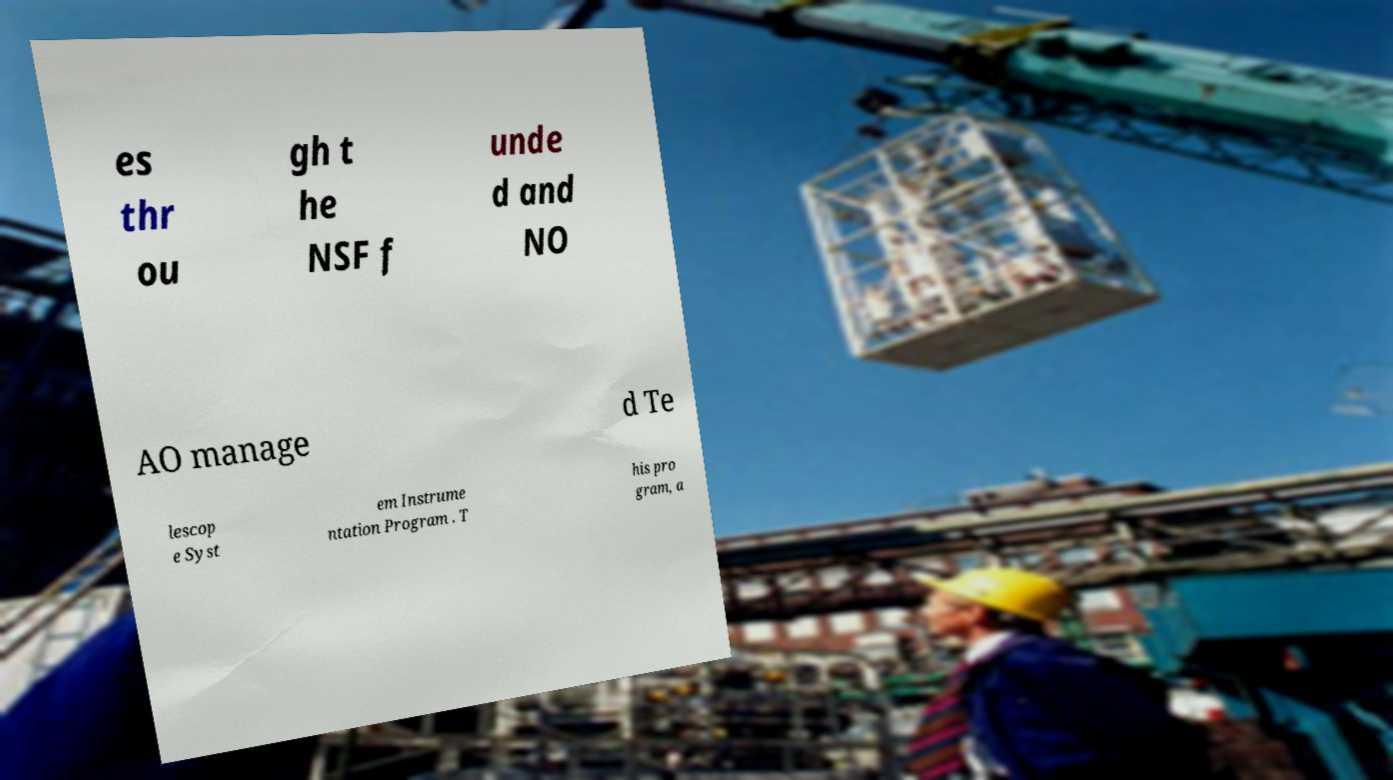Can you read and provide the text displayed in the image?This photo seems to have some interesting text. Can you extract and type it out for me? es thr ou gh t he NSF f unde d and NO AO manage d Te lescop e Syst em Instrume ntation Program . T his pro gram, a 